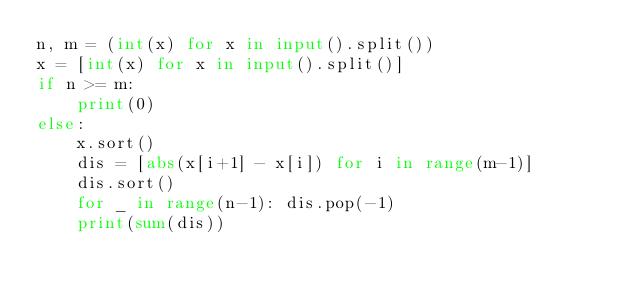<code> <loc_0><loc_0><loc_500><loc_500><_Python_>n, m = (int(x) for x in input().split())
x = [int(x) for x in input().split()]
if n >= m:
    print(0)
else:
    x.sort()
    dis = [abs(x[i+1] - x[i]) for i in range(m-1)]
    dis.sort()
    for _ in range(n-1): dis.pop(-1)
    print(sum(dis))</code> 